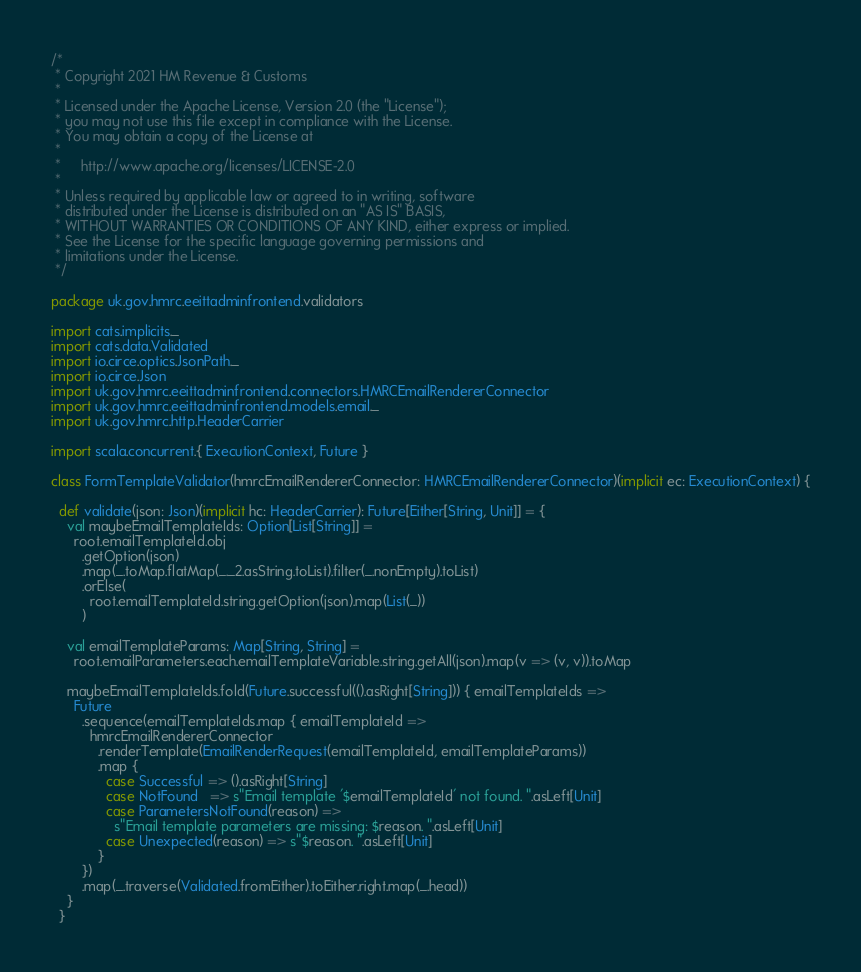Convert code to text. <code><loc_0><loc_0><loc_500><loc_500><_Scala_>/*
 * Copyright 2021 HM Revenue & Customs
 *
 * Licensed under the Apache License, Version 2.0 (the "License");
 * you may not use this file except in compliance with the License.
 * You may obtain a copy of the License at
 *
 *     http://www.apache.org/licenses/LICENSE-2.0
 *
 * Unless required by applicable law or agreed to in writing, software
 * distributed under the License is distributed on an "AS IS" BASIS,
 * WITHOUT WARRANTIES OR CONDITIONS OF ANY KIND, either express or implied.
 * See the License for the specific language governing permissions and
 * limitations under the License.
 */

package uk.gov.hmrc.eeittadminfrontend.validators

import cats.implicits._
import cats.data.Validated
import io.circe.optics.JsonPath._
import io.circe.Json
import uk.gov.hmrc.eeittadminfrontend.connectors.HMRCEmailRendererConnector
import uk.gov.hmrc.eeittadminfrontend.models.email._
import uk.gov.hmrc.http.HeaderCarrier

import scala.concurrent.{ ExecutionContext, Future }

class FormTemplateValidator(hmrcEmailRendererConnector: HMRCEmailRendererConnector)(implicit ec: ExecutionContext) {

  def validate(json: Json)(implicit hc: HeaderCarrier): Future[Either[String, Unit]] = {
    val maybeEmailTemplateIds: Option[List[String]] =
      root.emailTemplateId.obj
        .getOption(json)
        .map(_.toMap.flatMap(_._2.asString.toList).filter(_.nonEmpty).toList)
        .orElse(
          root.emailTemplateId.string.getOption(json).map(List(_))
        )

    val emailTemplateParams: Map[String, String] =
      root.emailParameters.each.emailTemplateVariable.string.getAll(json).map(v => (v, v)).toMap

    maybeEmailTemplateIds.fold(Future.successful(().asRight[String])) { emailTemplateIds =>
      Future
        .sequence(emailTemplateIds.map { emailTemplateId =>
          hmrcEmailRendererConnector
            .renderTemplate(EmailRenderRequest(emailTemplateId, emailTemplateParams))
            .map {
              case Successful => ().asRight[String]
              case NotFound   => s"Email template '$emailTemplateId' not found. ".asLeft[Unit]
              case ParametersNotFound(reason) =>
                s"Email template parameters are missing: $reason. ".asLeft[Unit]
              case Unexpected(reason) => s"$reason. ".asLeft[Unit]
            }
        })
        .map(_.traverse(Validated.fromEither).toEither.right.map(_.head))
    }
  }</code> 